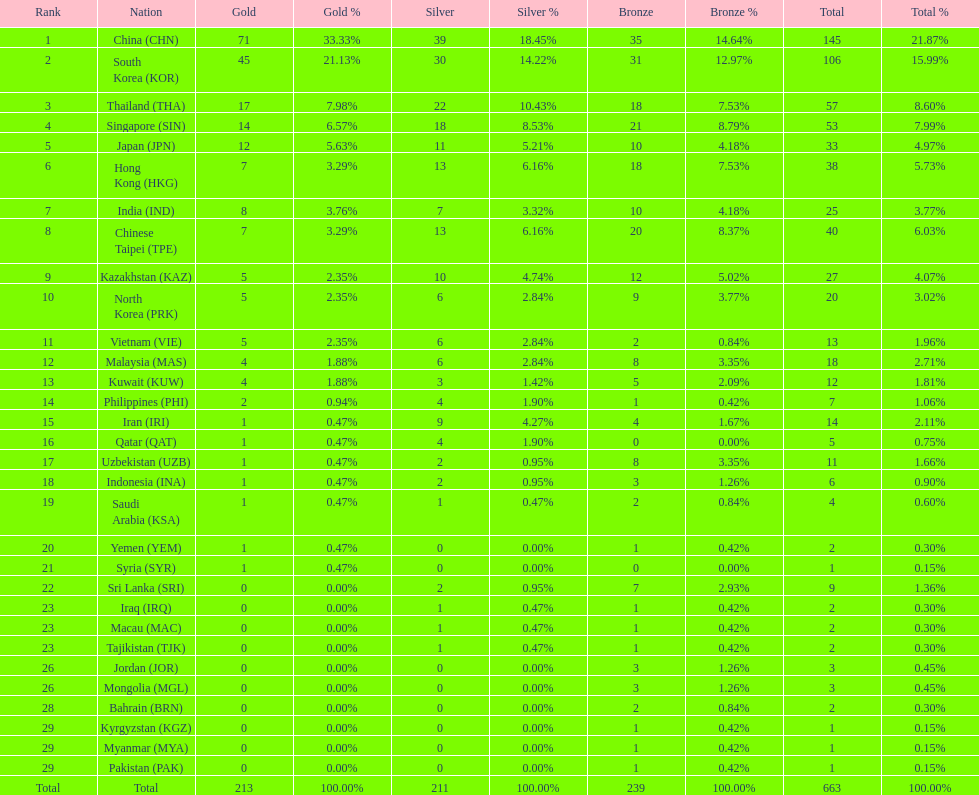How many nations earned at least ten bronze medals? 9. 